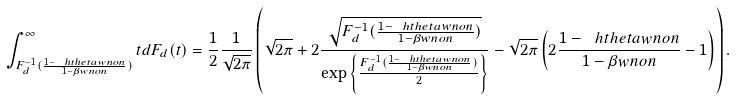<formula> <loc_0><loc_0><loc_500><loc_500>\int _ { F _ { d } ^ { - 1 } ( \frac { 1 - \ h t h e t a w n o n } { 1 - \beta w n o n } ) } ^ { \infty } t d F _ { d } ( t ) = \frac { 1 } { 2 } \frac { 1 } { \sqrt { 2 \pi } } \left ( \sqrt { 2 \pi } + 2 \frac { \sqrt { F _ { d } ^ { - 1 } ( \frac { 1 - \ h t h e t a w n o n } { 1 - \beta w n o n } ) } } { \exp \left \{ \frac { F _ { d } ^ { - 1 } ( \frac { 1 - \ h t h e t a w n o n } { 1 - \beta w n o n } ) } { 2 } \right \} } - \sqrt { 2 \pi } \left ( 2 \frac { 1 - \ h t h e t a w n o n } { 1 - \beta w n o n } - 1 \right ) \right ) .</formula> 